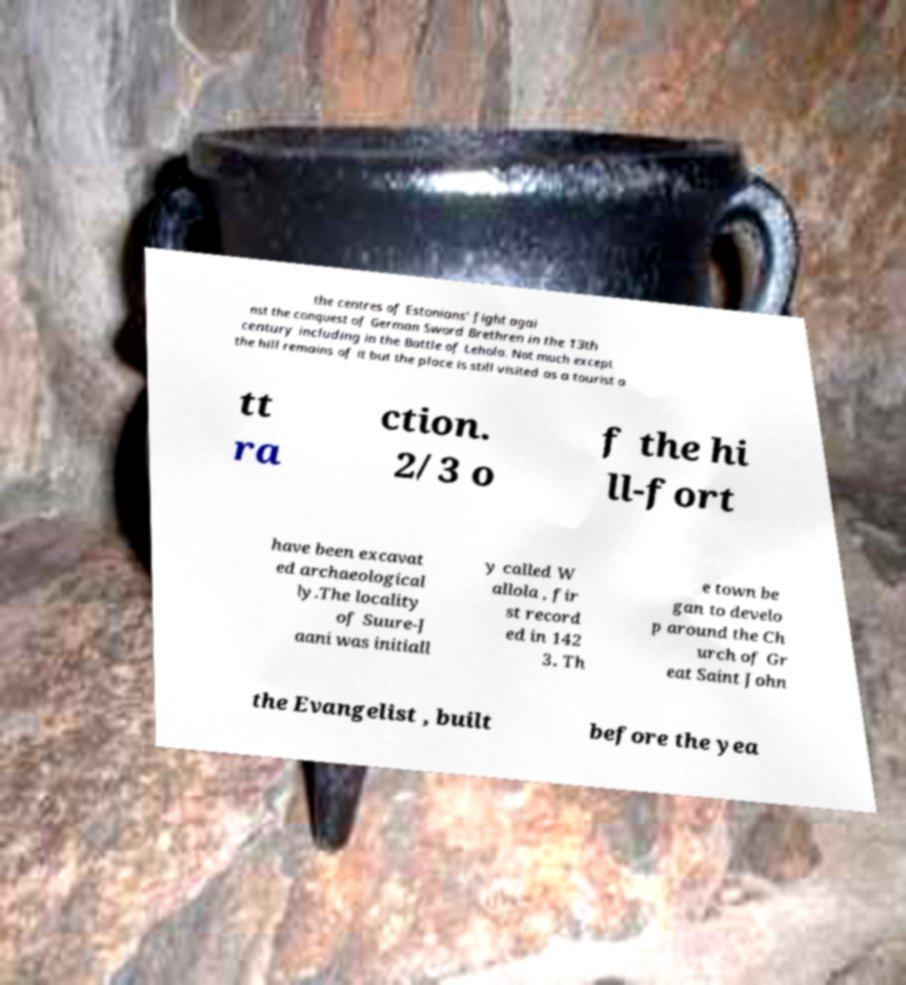Could you extract and type out the text from this image? the centres of Estonians' fight agai nst the conquest of German Sword Brethren in the 13th century including in the Battle of Lehola. Not much except the hill remains of it but the place is still visited as a tourist a tt ra ction. 2/3 o f the hi ll-fort have been excavat ed archaeological ly.The locality of Suure-J aani was initiall y called W allola , fir st record ed in 142 3. Th e town be gan to develo p around the Ch urch of Gr eat Saint John the Evangelist , built before the yea 